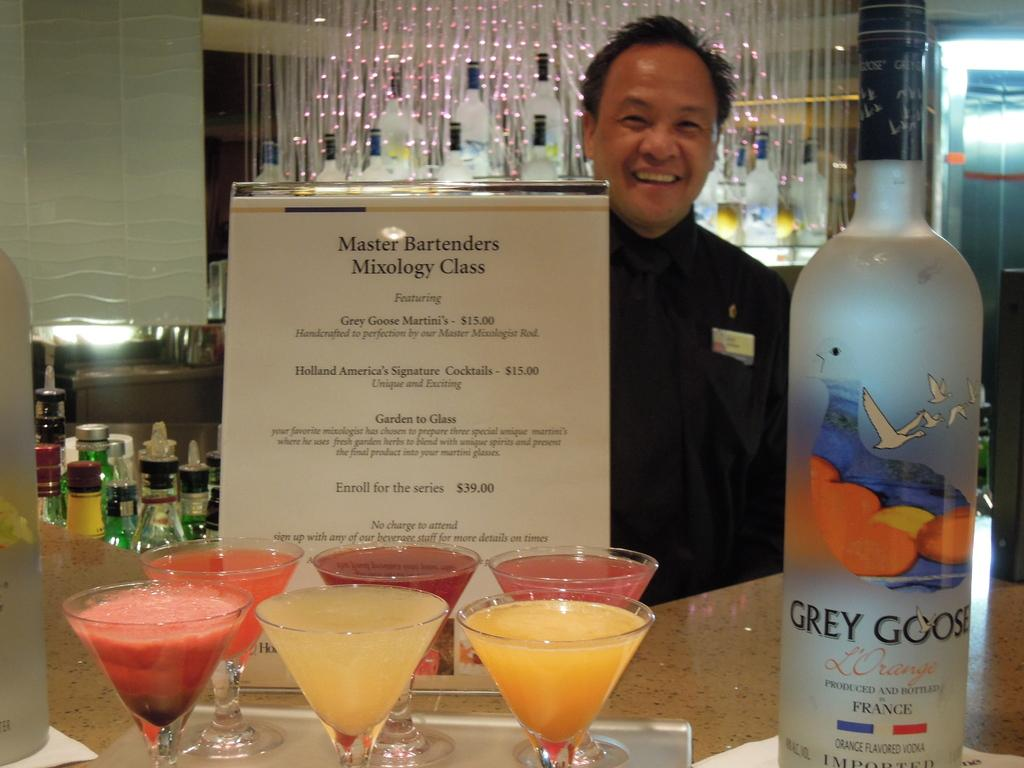What is the main subject in the middle of the image? There is a man standing in the middle of the image. What is the man's facial expression? The man is smiling. What is located at the bottom of the image? There is a table at the bottom of the image. What can be seen on the table? There are drinks and a bottle on the table. How many tickets are visible on the table in the image? There are no tickets visible on the table in the image. What type of rifle is being used by the man in the image? There is no rifle present in the image; the man is simply standing and smiling. 